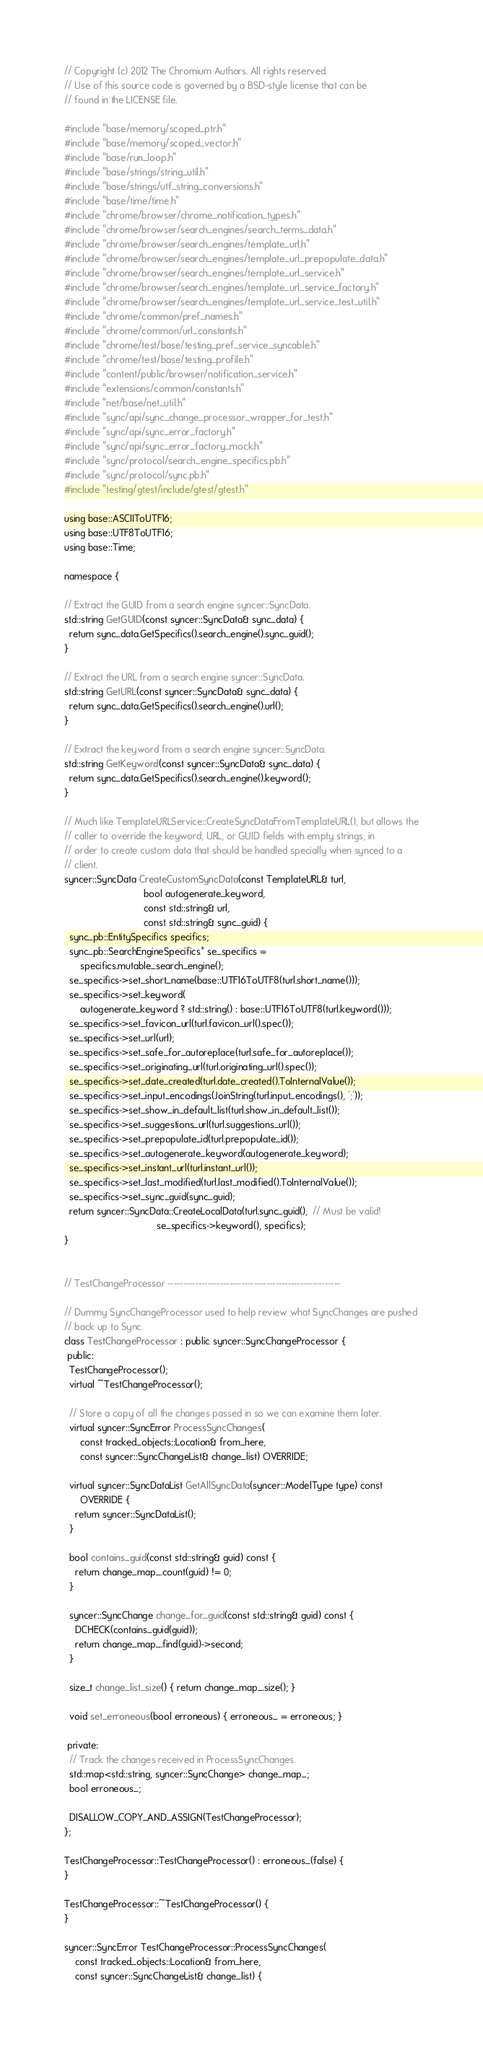Convert code to text. <code><loc_0><loc_0><loc_500><loc_500><_C++_>// Copyright (c) 2012 The Chromium Authors. All rights reserved.
// Use of this source code is governed by a BSD-style license that can be
// found in the LICENSE file.

#include "base/memory/scoped_ptr.h"
#include "base/memory/scoped_vector.h"
#include "base/run_loop.h"
#include "base/strings/string_util.h"
#include "base/strings/utf_string_conversions.h"
#include "base/time/time.h"
#include "chrome/browser/chrome_notification_types.h"
#include "chrome/browser/search_engines/search_terms_data.h"
#include "chrome/browser/search_engines/template_url.h"
#include "chrome/browser/search_engines/template_url_prepopulate_data.h"
#include "chrome/browser/search_engines/template_url_service.h"
#include "chrome/browser/search_engines/template_url_service_factory.h"
#include "chrome/browser/search_engines/template_url_service_test_util.h"
#include "chrome/common/pref_names.h"
#include "chrome/common/url_constants.h"
#include "chrome/test/base/testing_pref_service_syncable.h"
#include "chrome/test/base/testing_profile.h"
#include "content/public/browser/notification_service.h"
#include "extensions/common/constants.h"
#include "net/base/net_util.h"
#include "sync/api/sync_change_processor_wrapper_for_test.h"
#include "sync/api/sync_error_factory.h"
#include "sync/api/sync_error_factory_mock.h"
#include "sync/protocol/search_engine_specifics.pb.h"
#include "sync/protocol/sync.pb.h"
#include "testing/gtest/include/gtest/gtest.h"

using base::ASCIIToUTF16;
using base::UTF8ToUTF16;
using base::Time;

namespace {

// Extract the GUID from a search engine syncer::SyncData.
std::string GetGUID(const syncer::SyncData& sync_data) {
  return sync_data.GetSpecifics().search_engine().sync_guid();
}

// Extract the URL from a search engine syncer::SyncData.
std::string GetURL(const syncer::SyncData& sync_data) {
  return sync_data.GetSpecifics().search_engine().url();
}

// Extract the keyword from a search engine syncer::SyncData.
std::string GetKeyword(const syncer::SyncData& sync_data) {
  return sync_data.GetSpecifics().search_engine().keyword();
}

// Much like TemplateURLService::CreateSyncDataFromTemplateURL(), but allows the
// caller to override the keyword, URL, or GUID fields with empty strings, in
// order to create custom data that should be handled specially when synced to a
// client.
syncer::SyncData CreateCustomSyncData(const TemplateURL& turl,
                              bool autogenerate_keyword,
                              const std::string& url,
                              const std::string& sync_guid) {
  sync_pb::EntitySpecifics specifics;
  sync_pb::SearchEngineSpecifics* se_specifics =
      specifics.mutable_search_engine();
  se_specifics->set_short_name(base::UTF16ToUTF8(turl.short_name()));
  se_specifics->set_keyword(
      autogenerate_keyword ? std::string() : base::UTF16ToUTF8(turl.keyword()));
  se_specifics->set_favicon_url(turl.favicon_url().spec());
  se_specifics->set_url(url);
  se_specifics->set_safe_for_autoreplace(turl.safe_for_autoreplace());
  se_specifics->set_originating_url(turl.originating_url().spec());
  se_specifics->set_date_created(turl.date_created().ToInternalValue());
  se_specifics->set_input_encodings(JoinString(turl.input_encodings(), ';'));
  se_specifics->set_show_in_default_list(turl.show_in_default_list());
  se_specifics->set_suggestions_url(turl.suggestions_url());
  se_specifics->set_prepopulate_id(turl.prepopulate_id());
  se_specifics->set_autogenerate_keyword(autogenerate_keyword);
  se_specifics->set_instant_url(turl.instant_url());
  se_specifics->set_last_modified(turl.last_modified().ToInternalValue());
  se_specifics->set_sync_guid(sync_guid);
  return syncer::SyncData::CreateLocalData(turl.sync_guid(),  // Must be valid!
                                   se_specifics->keyword(), specifics);
}


// TestChangeProcessor --------------------------------------------------------

// Dummy SyncChangeProcessor used to help review what SyncChanges are pushed
// back up to Sync.
class TestChangeProcessor : public syncer::SyncChangeProcessor {
 public:
  TestChangeProcessor();
  virtual ~TestChangeProcessor();

  // Store a copy of all the changes passed in so we can examine them later.
  virtual syncer::SyncError ProcessSyncChanges(
      const tracked_objects::Location& from_here,
      const syncer::SyncChangeList& change_list) OVERRIDE;

  virtual syncer::SyncDataList GetAllSyncData(syncer::ModelType type) const
      OVERRIDE {
    return syncer::SyncDataList();
  }

  bool contains_guid(const std::string& guid) const {
    return change_map_.count(guid) != 0;
  }

  syncer::SyncChange change_for_guid(const std::string& guid) const {
    DCHECK(contains_guid(guid));
    return change_map_.find(guid)->second;
  }

  size_t change_list_size() { return change_map_.size(); }

  void set_erroneous(bool erroneous) { erroneous_ = erroneous; }

 private:
  // Track the changes received in ProcessSyncChanges.
  std::map<std::string, syncer::SyncChange> change_map_;
  bool erroneous_;

  DISALLOW_COPY_AND_ASSIGN(TestChangeProcessor);
};

TestChangeProcessor::TestChangeProcessor() : erroneous_(false) {
}

TestChangeProcessor::~TestChangeProcessor() {
}

syncer::SyncError TestChangeProcessor::ProcessSyncChanges(
    const tracked_objects::Location& from_here,
    const syncer::SyncChangeList& change_list) {</code> 